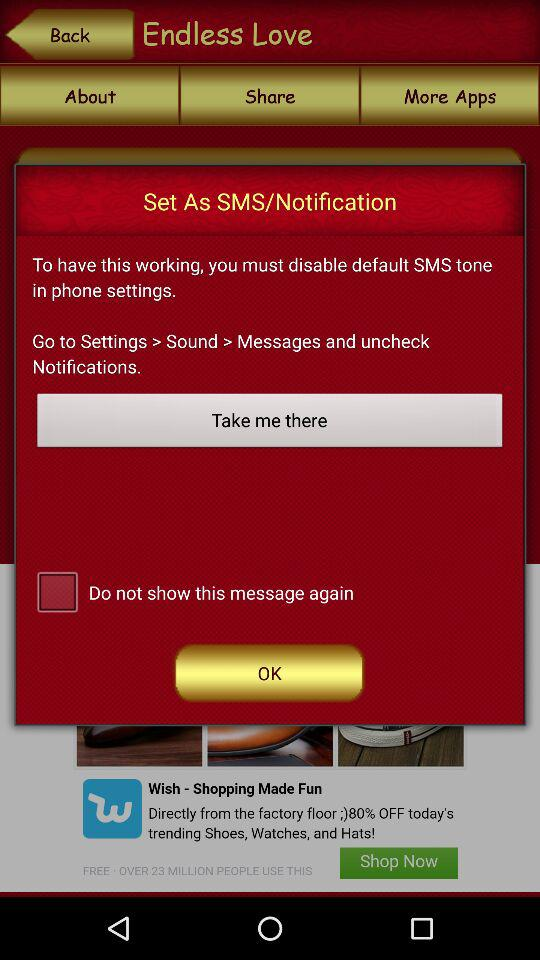Which apps are provided by the same developer?
When the provided information is insufficient, respond with <no answer>. <no answer> 